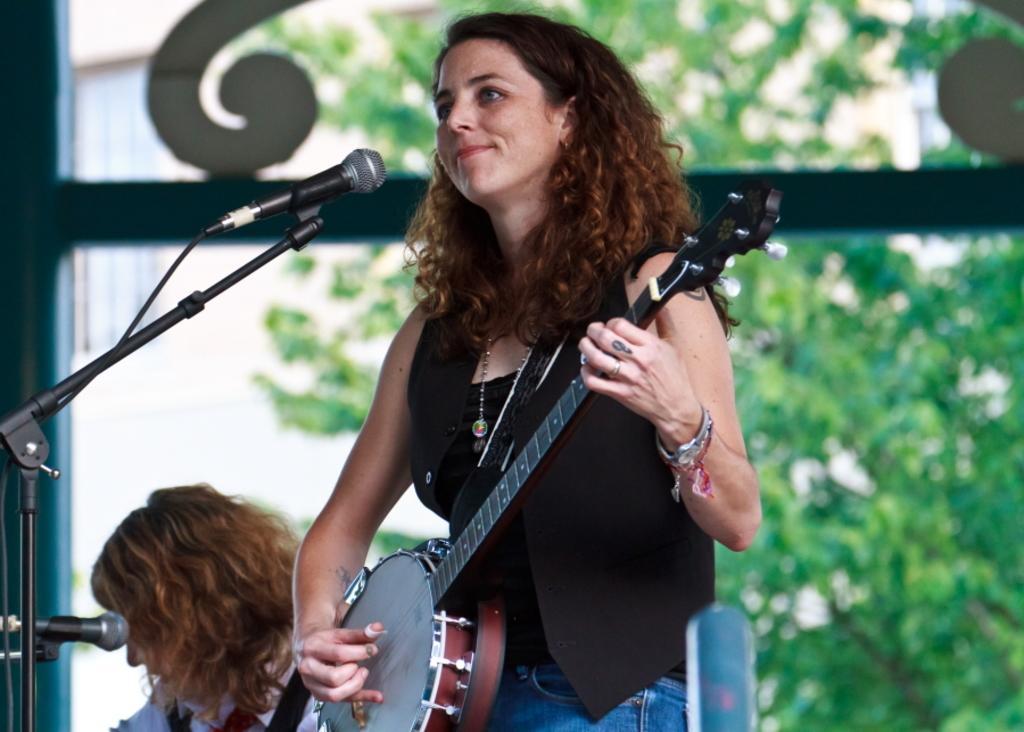Could you give a brief overview of what you see in this image? In this picture we can see a woman who is playing guitar. These are the mikes. On the background we can see some trees. 